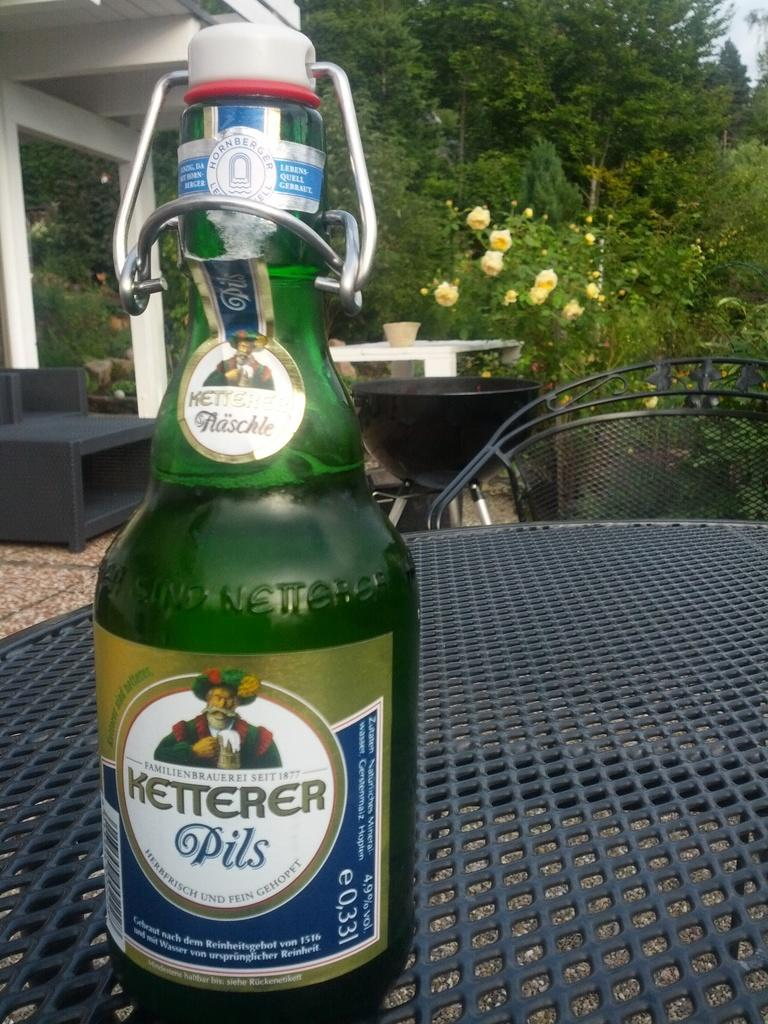<image>
Offer a succinct explanation of the picture presented. Green bottle of Ketterer pils drink outside on a table 